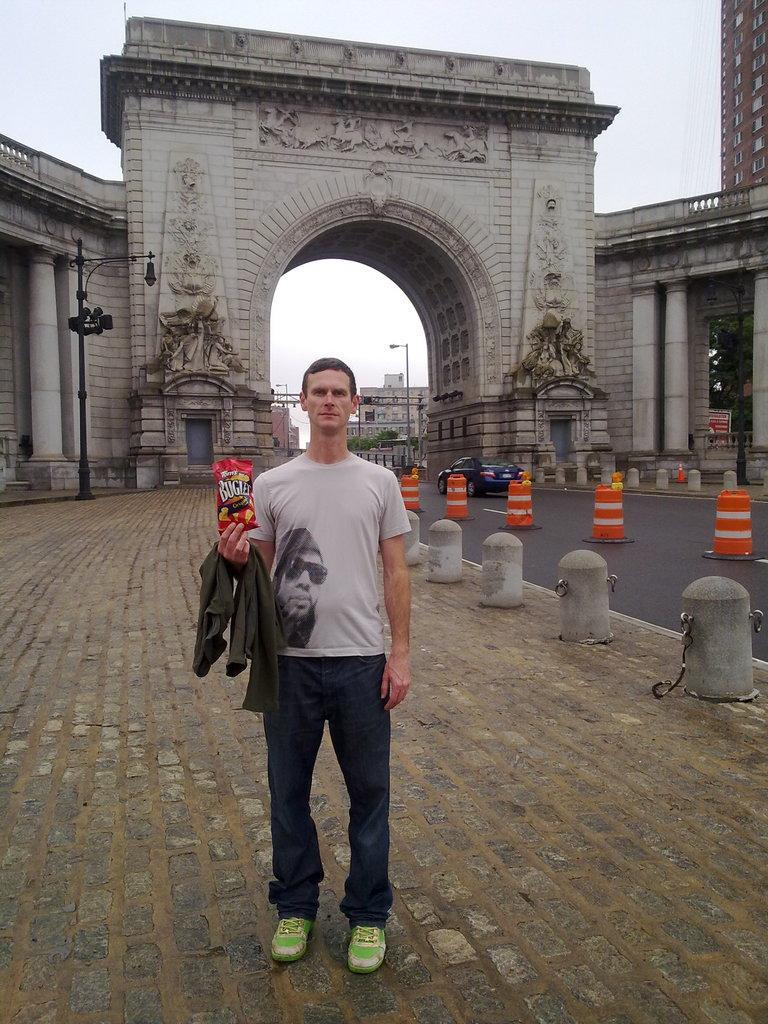In one or two sentences, can you explain what this image depicts? In this image we can see a man standing on the ground holding a cloth and a packet. We can also see some poles, buildings, a signboard, traffic poles, barriers, a car on the road and the sky which looks cloudy. 